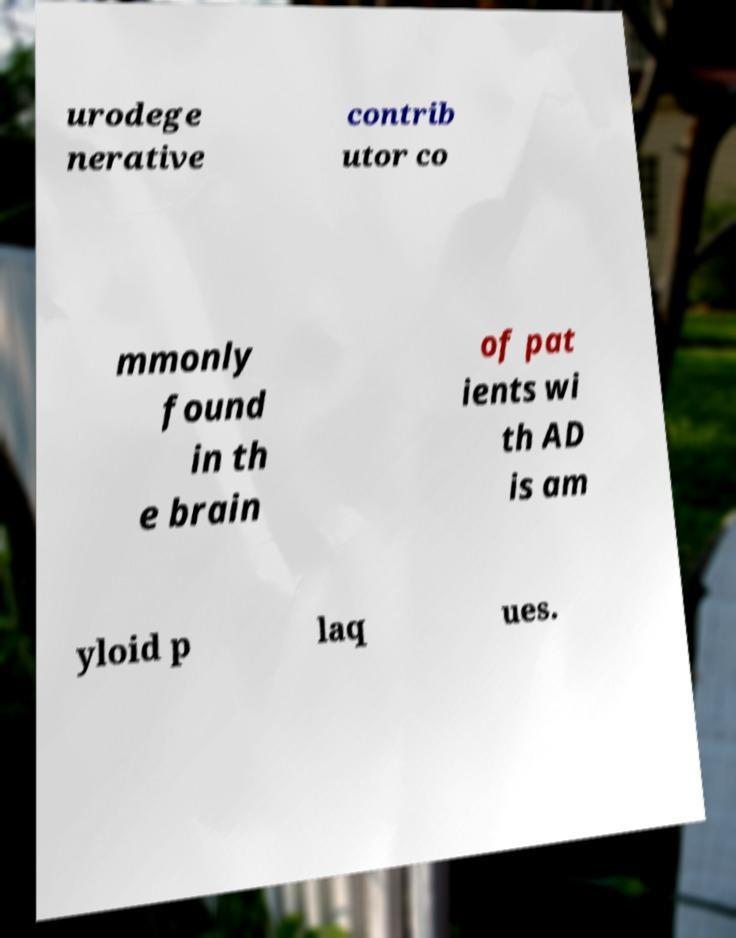Can you read and provide the text displayed in the image?This photo seems to have some interesting text. Can you extract and type it out for me? urodege nerative contrib utor co mmonly found in th e brain of pat ients wi th AD is am yloid p laq ues. 